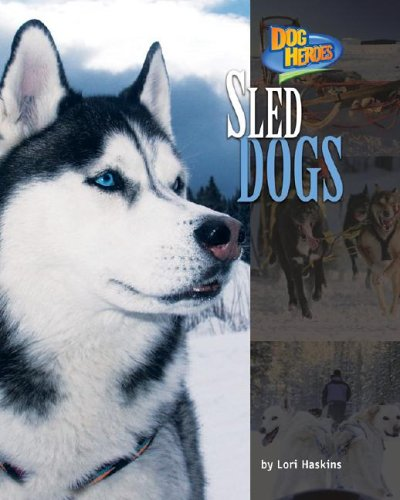What breed of sled dogs is featured on the cover? The breed featured prominently on the cover resembles a Siberian Husky, known for their thick fur, piercing blue eyes, and capability as sled dogs. Are Siberian Huskies the only breed used in sled dog racing? No, while Siberian Huskies are one of the most recognized breeds in sled dog racing, Alaskan Malamutes, Canadian Eskimo Dogs, and even mixed breeds are also commonly used in the sport. 